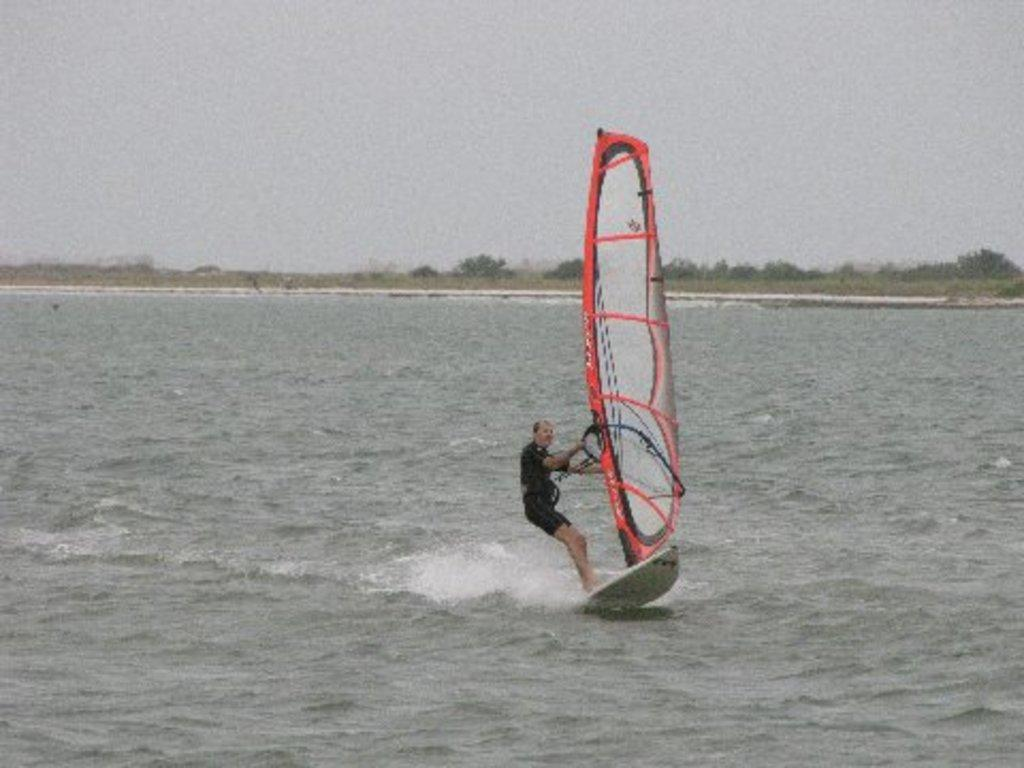Who is the main subject in the image? There is a man in the image. What is the man doing in the image? The man is wind surfing on the water. What can be seen in the background of the image? There are trees and the sky visible in the background of the image. How many yards of fabric are used to make the man's clothing in the image? There is no information about the man's clothing or the amount of fabric used in the image. 